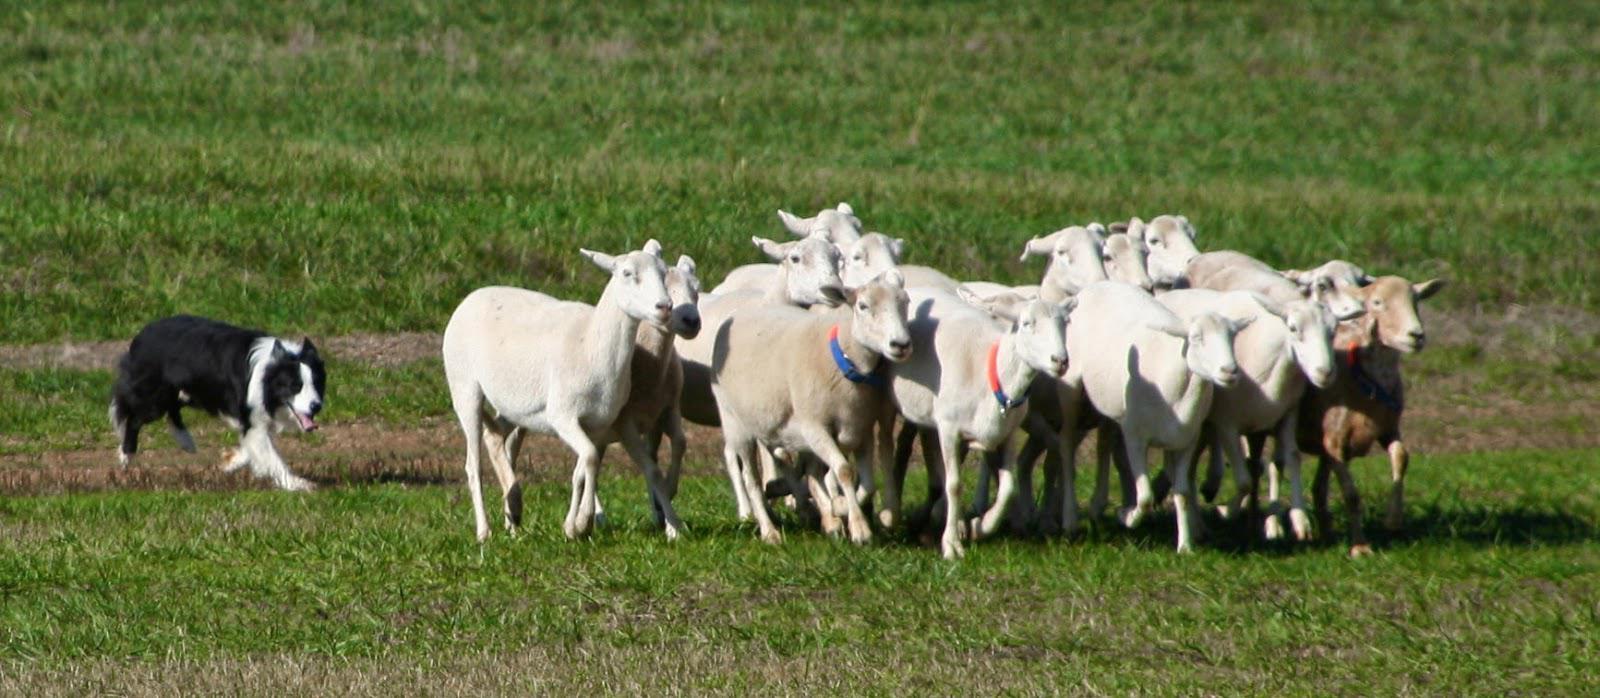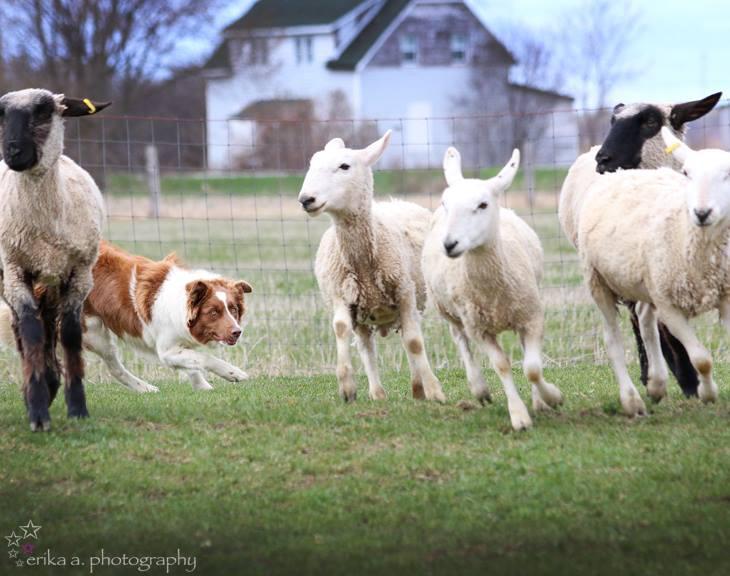The first image is the image on the left, the second image is the image on the right. For the images displayed, is the sentence "An image shows a man standing and holding onto something useful for herding the sheep in the picture." factually correct? Answer yes or no. No. The first image is the image on the left, the second image is the image on the right. Assess this claim about the two images: "A person is standing with the dog and sheep in one of the images.". Correct or not? Answer yes or no. No. 